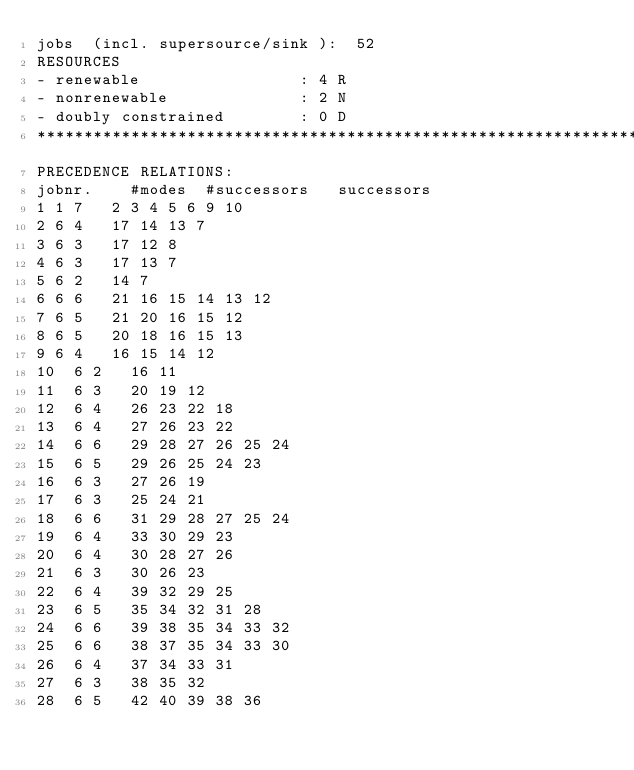Convert code to text. <code><loc_0><loc_0><loc_500><loc_500><_ObjectiveC_>jobs  (incl. supersource/sink ):	52
RESOURCES
- renewable                 : 4 R
- nonrenewable              : 2 N
- doubly constrained        : 0 D
************************************************************************
PRECEDENCE RELATIONS:
jobnr.    #modes  #successors   successors
1	1	7		2 3 4 5 6 9 10 
2	6	4		17 14 13 7 
3	6	3		17 12 8 
4	6	3		17 13 7 
5	6	2		14 7 
6	6	6		21 16 15 14 13 12 
7	6	5		21 20 16 15 12 
8	6	5		20 18 16 15 13 
9	6	4		16 15 14 12 
10	6	2		16 11 
11	6	3		20 19 12 
12	6	4		26 23 22 18 
13	6	4		27 26 23 22 
14	6	6		29 28 27 26 25 24 
15	6	5		29 26 25 24 23 
16	6	3		27 26 19 
17	6	3		25 24 21 
18	6	6		31 29 28 27 25 24 
19	6	4		33 30 29 23 
20	6	4		30 28 27 26 
21	6	3		30 26 23 
22	6	4		39 32 29 25 
23	6	5		35 34 32 31 28 
24	6	6		39 38 35 34 33 32 
25	6	6		38 37 35 34 33 30 
26	6	4		37 34 33 31 
27	6	3		38 35 32 
28	6	5		42 40 39 38 36 </code> 